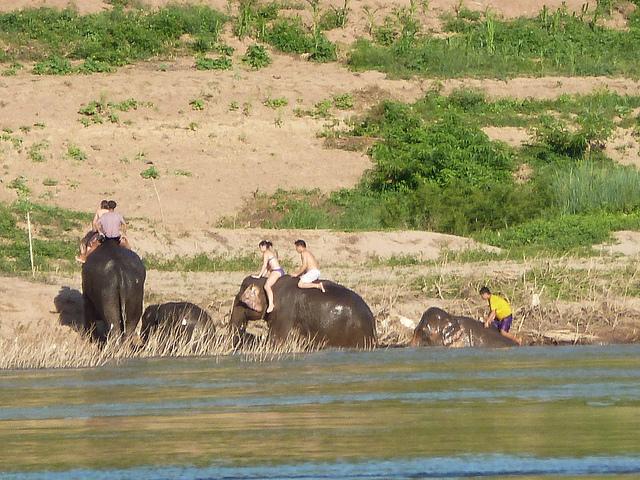Who rides the elephant?
Give a very brief answer. People. What kinds of elephants are these?
Keep it brief. African. What type of body of water are the elephants getting out of?
Write a very short answer. River. 